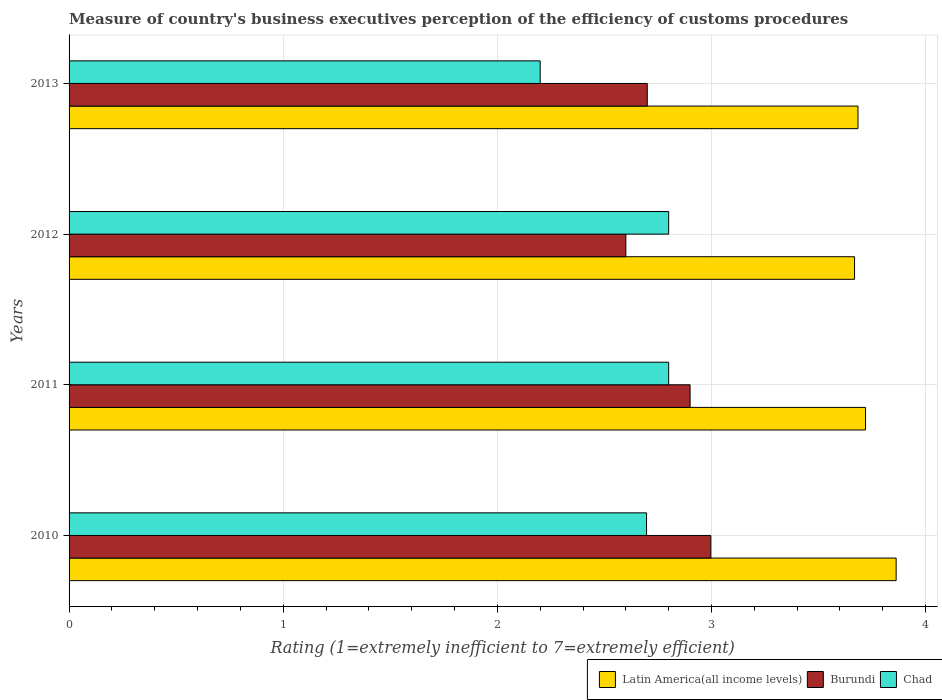How many different coloured bars are there?
Your response must be concise. 3. Are the number of bars per tick equal to the number of legend labels?
Your answer should be compact. Yes. Are the number of bars on each tick of the Y-axis equal?
Offer a terse response. Yes. What is the label of the 3rd group of bars from the top?
Ensure brevity in your answer.  2011. What is the rating of the efficiency of customs procedure in Latin America(all income levels) in 2011?
Offer a very short reply. 3.72. Across all years, what is the maximum rating of the efficiency of customs procedure in Latin America(all income levels)?
Keep it short and to the point. 3.86. Across all years, what is the minimum rating of the efficiency of customs procedure in Burundi?
Provide a succinct answer. 2.6. In which year was the rating of the efficiency of customs procedure in Burundi maximum?
Ensure brevity in your answer.  2010. In which year was the rating of the efficiency of customs procedure in Chad minimum?
Provide a succinct answer. 2013. What is the total rating of the efficiency of customs procedure in Latin America(all income levels) in the graph?
Offer a very short reply. 14.93. What is the difference between the rating of the efficiency of customs procedure in Latin America(all income levels) in 2010 and that in 2011?
Give a very brief answer. 0.14. What is the difference between the rating of the efficiency of customs procedure in Latin America(all income levels) in 2010 and the rating of the efficiency of customs procedure in Chad in 2012?
Your answer should be very brief. 1.06. What is the average rating of the efficiency of customs procedure in Chad per year?
Offer a very short reply. 2.62. In the year 2011, what is the difference between the rating of the efficiency of customs procedure in Burundi and rating of the efficiency of customs procedure in Chad?
Your answer should be compact. 0.1. What is the ratio of the rating of the efficiency of customs procedure in Latin America(all income levels) in 2011 to that in 2013?
Give a very brief answer. 1.01. Is the rating of the efficiency of customs procedure in Chad in 2011 less than that in 2013?
Make the answer very short. No. What is the difference between the highest and the second highest rating of the efficiency of customs procedure in Burundi?
Ensure brevity in your answer.  0.1. What is the difference between the highest and the lowest rating of the efficiency of customs procedure in Latin America(all income levels)?
Your answer should be compact. 0.19. What does the 2nd bar from the top in 2010 represents?
Offer a terse response. Burundi. What does the 1st bar from the bottom in 2012 represents?
Ensure brevity in your answer.  Latin America(all income levels). Is it the case that in every year, the sum of the rating of the efficiency of customs procedure in Chad and rating of the efficiency of customs procedure in Burundi is greater than the rating of the efficiency of customs procedure in Latin America(all income levels)?
Make the answer very short. Yes. How many bars are there?
Your answer should be very brief. 12. What is the difference between two consecutive major ticks on the X-axis?
Ensure brevity in your answer.  1. Are the values on the major ticks of X-axis written in scientific E-notation?
Your answer should be very brief. No. Where does the legend appear in the graph?
Provide a succinct answer. Bottom right. What is the title of the graph?
Your answer should be compact. Measure of country's business executives perception of the efficiency of customs procedures. What is the label or title of the X-axis?
Offer a terse response. Rating (1=extremely inefficient to 7=extremely efficient). What is the label or title of the Y-axis?
Your answer should be very brief. Years. What is the Rating (1=extremely inefficient to 7=extremely efficient) of Latin America(all income levels) in 2010?
Make the answer very short. 3.86. What is the Rating (1=extremely inefficient to 7=extremely efficient) in Burundi in 2010?
Your answer should be very brief. 3. What is the Rating (1=extremely inefficient to 7=extremely efficient) of Chad in 2010?
Your answer should be compact. 2.7. What is the Rating (1=extremely inefficient to 7=extremely efficient) of Latin America(all income levels) in 2011?
Provide a short and direct response. 3.72. What is the Rating (1=extremely inefficient to 7=extremely efficient) in Burundi in 2011?
Your answer should be very brief. 2.9. What is the Rating (1=extremely inefficient to 7=extremely efficient) in Chad in 2011?
Keep it short and to the point. 2.8. What is the Rating (1=extremely inefficient to 7=extremely efficient) in Latin America(all income levels) in 2012?
Offer a terse response. 3.67. What is the Rating (1=extremely inefficient to 7=extremely efficient) of Burundi in 2012?
Your answer should be compact. 2.6. What is the Rating (1=extremely inefficient to 7=extremely efficient) of Chad in 2012?
Provide a short and direct response. 2.8. What is the Rating (1=extremely inefficient to 7=extremely efficient) of Latin America(all income levels) in 2013?
Give a very brief answer. 3.68. Across all years, what is the maximum Rating (1=extremely inefficient to 7=extremely efficient) in Latin America(all income levels)?
Your answer should be very brief. 3.86. Across all years, what is the maximum Rating (1=extremely inefficient to 7=extremely efficient) of Burundi?
Offer a very short reply. 3. Across all years, what is the maximum Rating (1=extremely inefficient to 7=extremely efficient) in Chad?
Keep it short and to the point. 2.8. Across all years, what is the minimum Rating (1=extremely inefficient to 7=extremely efficient) of Latin America(all income levels)?
Keep it short and to the point. 3.67. Across all years, what is the minimum Rating (1=extremely inefficient to 7=extremely efficient) in Burundi?
Give a very brief answer. 2.6. Across all years, what is the minimum Rating (1=extremely inefficient to 7=extremely efficient) in Chad?
Provide a short and direct response. 2.2. What is the total Rating (1=extremely inefficient to 7=extremely efficient) in Latin America(all income levels) in the graph?
Give a very brief answer. 14.93. What is the total Rating (1=extremely inefficient to 7=extremely efficient) of Burundi in the graph?
Offer a very short reply. 11.2. What is the total Rating (1=extremely inefficient to 7=extremely efficient) of Chad in the graph?
Your answer should be compact. 10.5. What is the difference between the Rating (1=extremely inefficient to 7=extremely efficient) of Latin America(all income levels) in 2010 and that in 2011?
Offer a very short reply. 0.14. What is the difference between the Rating (1=extremely inefficient to 7=extremely efficient) of Burundi in 2010 and that in 2011?
Offer a terse response. 0.1. What is the difference between the Rating (1=extremely inefficient to 7=extremely efficient) in Chad in 2010 and that in 2011?
Your answer should be compact. -0.1. What is the difference between the Rating (1=extremely inefficient to 7=extremely efficient) in Latin America(all income levels) in 2010 and that in 2012?
Provide a short and direct response. 0.19. What is the difference between the Rating (1=extremely inefficient to 7=extremely efficient) of Burundi in 2010 and that in 2012?
Provide a succinct answer. 0.4. What is the difference between the Rating (1=extremely inefficient to 7=extremely efficient) of Chad in 2010 and that in 2012?
Make the answer very short. -0.1. What is the difference between the Rating (1=extremely inefficient to 7=extremely efficient) of Latin America(all income levels) in 2010 and that in 2013?
Make the answer very short. 0.18. What is the difference between the Rating (1=extremely inefficient to 7=extremely efficient) of Burundi in 2010 and that in 2013?
Ensure brevity in your answer.  0.3. What is the difference between the Rating (1=extremely inefficient to 7=extremely efficient) in Chad in 2010 and that in 2013?
Provide a succinct answer. 0.5. What is the difference between the Rating (1=extremely inefficient to 7=extremely efficient) in Latin America(all income levels) in 2011 and that in 2012?
Your answer should be very brief. 0.05. What is the difference between the Rating (1=extremely inefficient to 7=extremely efficient) in Burundi in 2011 and that in 2012?
Your answer should be compact. 0.3. What is the difference between the Rating (1=extremely inefficient to 7=extremely efficient) in Chad in 2011 and that in 2012?
Ensure brevity in your answer.  0. What is the difference between the Rating (1=extremely inefficient to 7=extremely efficient) in Latin America(all income levels) in 2011 and that in 2013?
Offer a terse response. 0.04. What is the difference between the Rating (1=extremely inefficient to 7=extremely efficient) of Burundi in 2011 and that in 2013?
Offer a very short reply. 0.2. What is the difference between the Rating (1=extremely inefficient to 7=extremely efficient) in Latin America(all income levels) in 2012 and that in 2013?
Your response must be concise. -0.02. What is the difference between the Rating (1=extremely inefficient to 7=extremely efficient) in Chad in 2012 and that in 2013?
Ensure brevity in your answer.  0.6. What is the difference between the Rating (1=extremely inefficient to 7=extremely efficient) of Latin America(all income levels) in 2010 and the Rating (1=extremely inefficient to 7=extremely efficient) of Burundi in 2011?
Offer a very short reply. 0.96. What is the difference between the Rating (1=extremely inefficient to 7=extremely efficient) of Latin America(all income levels) in 2010 and the Rating (1=extremely inefficient to 7=extremely efficient) of Chad in 2011?
Provide a short and direct response. 1.06. What is the difference between the Rating (1=extremely inefficient to 7=extremely efficient) in Burundi in 2010 and the Rating (1=extremely inefficient to 7=extremely efficient) in Chad in 2011?
Your answer should be very brief. 0.2. What is the difference between the Rating (1=extremely inefficient to 7=extremely efficient) in Latin America(all income levels) in 2010 and the Rating (1=extremely inefficient to 7=extremely efficient) in Burundi in 2012?
Your answer should be very brief. 1.26. What is the difference between the Rating (1=extremely inefficient to 7=extremely efficient) of Latin America(all income levels) in 2010 and the Rating (1=extremely inefficient to 7=extremely efficient) of Chad in 2012?
Provide a short and direct response. 1.06. What is the difference between the Rating (1=extremely inefficient to 7=extremely efficient) in Burundi in 2010 and the Rating (1=extremely inefficient to 7=extremely efficient) in Chad in 2012?
Provide a succinct answer. 0.2. What is the difference between the Rating (1=extremely inefficient to 7=extremely efficient) in Latin America(all income levels) in 2010 and the Rating (1=extremely inefficient to 7=extremely efficient) in Burundi in 2013?
Keep it short and to the point. 1.16. What is the difference between the Rating (1=extremely inefficient to 7=extremely efficient) in Latin America(all income levels) in 2010 and the Rating (1=extremely inefficient to 7=extremely efficient) in Chad in 2013?
Your answer should be compact. 1.66. What is the difference between the Rating (1=extremely inefficient to 7=extremely efficient) in Burundi in 2010 and the Rating (1=extremely inefficient to 7=extremely efficient) in Chad in 2013?
Your answer should be compact. 0.8. What is the difference between the Rating (1=extremely inefficient to 7=extremely efficient) of Latin America(all income levels) in 2011 and the Rating (1=extremely inefficient to 7=extremely efficient) of Burundi in 2012?
Provide a succinct answer. 1.12. What is the difference between the Rating (1=extremely inefficient to 7=extremely efficient) in Latin America(all income levels) in 2011 and the Rating (1=extremely inefficient to 7=extremely efficient) in Chad in 2012?
Your answer should be very brief. 0.92. What is the difference between the Rating (1=extremely inefficient to 7=extremely efficient) in Latin America(all income levels) in 2011 and the Rating (1=extremely inefficient to 7=extremely efficient) in Burundi in 2013?
Provide a succinct answer. 1.02. What is the difference between the Rating (1=extremely inefficient to 7=extremely efficient) in Latin America(all income levels) in 2011 and the Rating (1=extremely inefficient to 7=extremely efficient) in Chad in 2013?
Offer a terse response. 1.52. What is the difference between the Rating (1=extremely inefficient to 7=extremely efficient) in Latin America(all income levels) in 2012 and the Rating (1=extremely inefficient to 7=extremely efficient) in Chad in 2013?
Offer a very short reply. 1.47. What is the difference between the Rating (1=extremely inefficient to 7=extremely efficient) of Burundi in 2012 and the Rating (1=extremely inefficient to 7=extremely efficient) of Chad in 2013?
Your response must be concise. 0.4. What is the average Rating (1=extremely inefficient to 7=extremely efficient) of Latin America(all income levels) per year?
Give a very brief answer. 3.73. What is the average Rating (1=extremely inefficient to 7=extremely efficient) of Burundi per year?
Your answer should be very brief. 2.8. What is the average Rating (1=extremely inefficient to 7=extremely efficient) of Chad per year?
Your answer should be compact. 2.62. In the year 2010, what is the difference between the Rating (1=extremely inefficient to 7=extremely efficient) of Latin America(all income levels) and Rating (1=extremely inefficient to 7=extremely efficient) of Burundi?
Offer a very short reply. 0.87. In the year 2010, what is the difference between the Rating (1=extremely inefficient to 7=extremely efficient) of Latin America(all income levels) and Rating (1=extremely inefficient to 7=extremely efficient) of Chad?
Give a very brief answer. 1.17. In the year 2010, what is the difference between the Rating (1=extremely inefficient to 7=extremely efficient) of Burundi and Rating (1=extremely inefficient to 7=extremely efficient) of Chad?
Make the answer very short. 0.3. In the year 2011, what is the difference between the Rating (1=extremely inefficient to 7=extremely efficient) in Latin America(all income levels) and Rating (1=extremely inefficient to 7=extremely efficient) in Burundi?
Ensure brevity in your answer.  0.82. In the year 2011, what is the difference between the Rating (1=extremely inefficient to 7=extremely efficient) in Latin America(all income levels) and Rating (1=extremely inefficient to 7=extremely efficient) in Chad?
Provide a short and direct response. 0.92. In the year 2012, what is the difference between the Rating (1=extremely inefficient to 7=extremely efficient) of Latin America(all income levels) and Rating (1=extremely inefficient to 7=extremely efficient) of Burundi?
Your response must be concise. 1.07. In the year 2012, what is the difference between the Rating (1=extremely inefficient to 7=extremely efficient) in Latin America(all income levels) and Rating (1=extremely inefficient to 7=extremely efficient) in Chad?
Offer a terse response. 0.87. In the year 2012, what is the difference between the Rating (1=extremely inefficient to 7=extremely efficient) of Burundi and Rating (1=extremely inefficient to 7=extremely efficient) of Chad?
Give a very brief answer. -0.2. In the year 2013, what is the difference between the Rating (1=extremely inefficient to 7=extremely efficient) of Latin America(all income levels) and Rating (1=extremely inefficient to 7=extremely efficient) of Burundi?
Keep it short and to the point. 0.98. In the year 2013, what is the difference between the Rating (1=extremely inefficient to 7=extremely efficient) of Latin America(all income levels) and Rating (1=extremely inefficient to 7=extremely efficient) of Chad?
Keep it short and to the point. 1.48. In the year 2013, what is the difference between the Rating (1=extremely inefficient to 7=extremely efficient) in Burundi and Rating (1=extremely inefficient to 7=extremely efficient) in Chad?
Your answer should be very brief. 0.5. What is the ratio of the Rating (1=extremely inefficient to 7=extremely efficient) of Latin America(all income levels) in 2010 to that in 2011?
Give a very brief answer. 1.04. What is the ratio of the Rating (1=extremely inefficient to 7=extremely efficient) in Burundi in 2010 to that in 2011?
Offer a terse response. 1.03. What is the ratio of the Rating (1=extremely inefficient to 7=extremely efficient) in Chad in 2010 to that in 2011?
Provide a succinct answer. 0.96. What is the ratio of the Rating (1=extremely inefficient to 7=extremely efficient) of Latin America(all income levels) in 2010 to that in 2012?
Make the answer very short. 1.05. What is the ratio of the Rating (1=extremely inefficient to 7=extremely efficient) in Burundi in 2010 to that in 2012?
Keep it short and to the point. 1.15. What is the ratio of the Rating (1=extremely inefficient to 7=extremely efficient) of Chad in 2010 to that in 2012?
Make the answer very short. 0.96. What is the ratio of the Rating (1=extremely inefficient to 7=extremely efficient) of Latin America(all income levels) in 2010 to that in 2013?
Provide a succinct answer. 1.05. What is the ratio of the Rating (1=extremely inefficient to 7=extremely efficient) in Burundi in 2010 to that in 2013?
Make the answer very short. 1.11. What is the ratio of the Rating (1=extremely inefficient to 7=extremely efficient) in Chad in 2010 to that in 2013?
Keep it short and to the point. 1.23. What is the ratio of the Rating (1=extremely inefficient to 7=extremely efficient) of Burundi in 2011 to that in 2012?
Your answer should be compact. 1.12. What is the ratio of the Rating (1=extremely inefficient to 7=extremely efficient) in Chad in 2011 to that in 2012?
Your answer should be compact. 1. What is the ratio of the Rating (1=extremely inefficient to 7=extremely efficient) in Latin America(all income levels) in 2011 to that in 2013?
Ensure brevity in your answer.  1.01. What is the ratio of the Rating (1=extremely inefficient to 7=extremely efficient) of Burundi in 2011 to that in 2013?
Your response must be concise. 1.07. What is the ratio of the Rating (1=extremely inefficient to 7=extremely efficient) of Chad in 2011 to that in 2013?
Offer a very short reply. 1.27. What is the ratio of the Rating (1=extremely inefficient to 7=extremely efficient) of Chad in 2012 to that in 2013?
Your answer should be very brief. 1.27. What is the difference between the highest and the second highest Rating (1=extremely inefficient to 7=extremely efficient) in Latin America(all income levels)?
Provide a short and direct response. 0.14. What is the difference between the highest and the second highest Rating (1=extremely inefficient to 7=extremely efficient) in Burundi?
Make the answer very short. 0.1. What is the difference between the highest and the second highest Rating (1=extremely inefficient to 7=extremely efficient) in Chad?
Give a very brief answer. 0. What is the difference between the highest and the lowest Rating (1=extremely inefficient to 7=extremely efficient) of Latin America(all income levels)?
Provide a succinct answer. 0.19. What is the difference between the highest and the lowest Rating (1=extremely inefficient to 7=extremely efficient) in Burundi?
Your response must be concise. 0.4. 